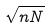<formula> <loc_0><loc_0><loc_500><loc_500>\sqrt { n N }</formula> 